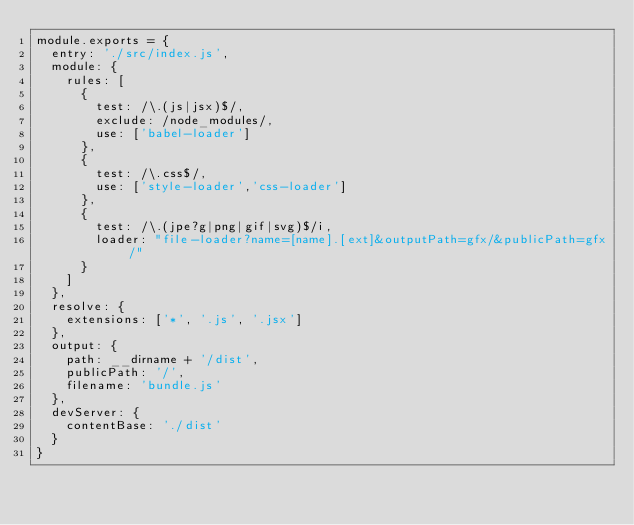<code> <loc_0><loc_0><loc_500><loc_500><_JavaScript_>module.exports = {
	entry: './src/index.js',
	module: {
		rules: [
			{
				test: /\.(js|jsx)$/,
				exclude: /node_modules/,
				use: ['babel-loader']
			},
			{
				test: /\.css$/,
				use: ['style-loader','css-loader']
			},
			{
				test: /\.(jpe?g|png|gif|svg)$/i,
				loader: "file-loader?name=[name].[ext]&outputPath=gfx/&publicPath=gfx/"
			}
		]
	},
	resolve: {
		extensions: ['*', '.js', '.jsx']
	},
	output: {
		path: __dirname + '/dist',
		publicPath: '/',
		filename: 'bundle.js'
	},
	devServer: {
		contentBase: './dist'
	}
}
</code> 